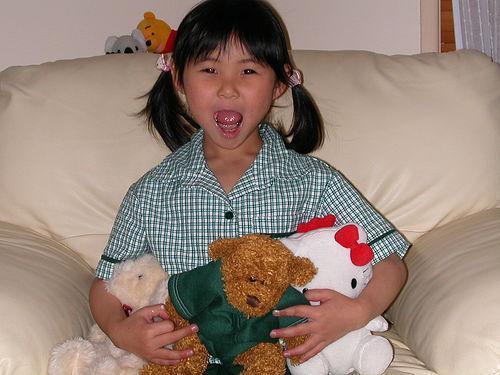How many stuffed animals are in the picture?
Give a very brief answer. 5. How many teddy bears are visible?
Give a very brief answer. 2. How many hot dogs are on the plate?
Give a very brief answer. 0. 